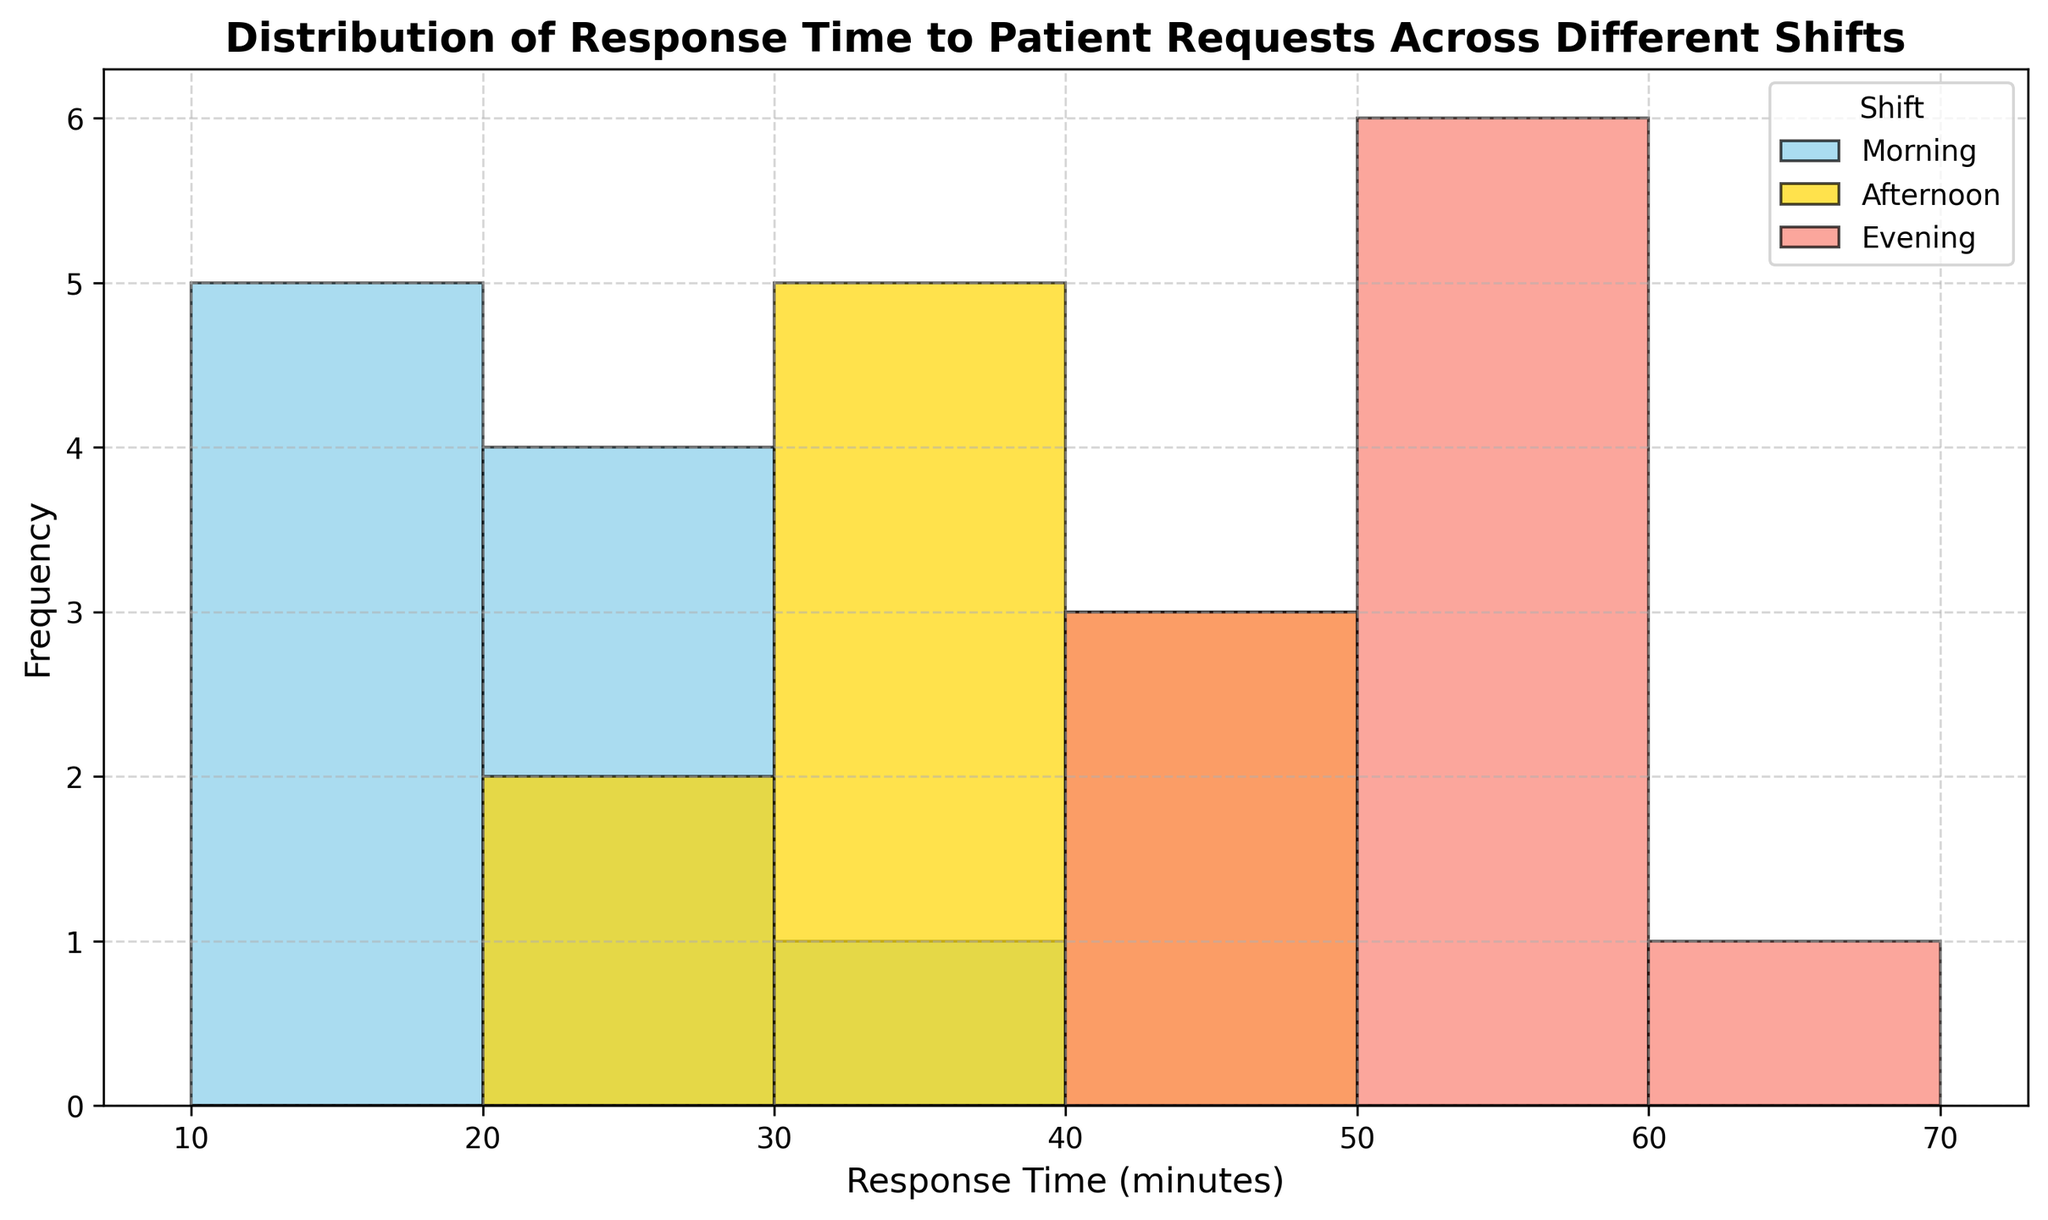What is the most frequent response time range for the Morning shift? To determine this, look at the histogram bars associated with the morning shift color (skyblue). The tallest bar within these is the most frequent range. The morning shift shows a tall bar in the 10-20 minute range.
Answer: 10-20 minutes Which shift has the highest range of response times? Observe the bins for each shift color to determine the range. The morning shift ranges from 10 to 30 minutes, the afternoon shift ranges from 25 to 45 minutes, and the evening shift ranges from 47 to 60 minutes. The evening shift has the broadest range, 13 minutes.
Answer: Evening What is the median response time for the Afternoon shift? To find the median, sort the afternoon shift response times and find the middle value. The response times are 25, 28, 30, 32, 33, 35, 38, 40, 42, and 45. The median value is the 5th and 6th values averaged, (33+35)/2 = 34.
Answer: 34 minutes Which shift has the largest spread in response times? The spread is determined by subtracting the minimum from the maximum response time within each shift. For the Morning shift: 30-10=20 minutes; for the Afternoon: 45-25=20 minutes; for the Evening: 60-47=13 minutes. The Morning and Afternoon shifts have the largest spreads at 20 minutes.
Answer: Morning and Afternoon Which shift has the lowest frequency of response times in the 30-40 minute range? Examine the height of the histogram bars in the 30-40 minute range for each color representing a shift. The morning shift has no bars in this range, indicating the lowest (zero) frequency.
Answer: Morning What fraction of response times in the Evening shift are greater than 50 minutes? Count the number of bins above the 50-minute mark and divide by the total number of evening responses. There are 4 bins (55, 60, 53, 58 minutes) above 50 minutes out of 10 total evening responses. Thus, the fraction is 4/10 or 0.4.
Answer: 0.4 Compare the frequency of response times between 10-20 minutes for Morning and Evening shifts. Which has more? For the Morning shift, count the height of the bars between 10-20 minutes. The Morning shift has 4 bars, while the Evening shift has zero bars in this range.
Answer: Morning shift What is the interquartile range (IQR) for the Morning shift? To calculate the IQR, first find the 1st quartile (Q1, 25th percentile) and 3rd quartile (Q3, 75th percentile) of the Morning shift data. The sorted data: 10, 12, 14, 15, 18, 20, 22, 25, 27, 30. Q1 is the 3rd value, 14, and Q3 is the 8th value, 25. IQR = Q3 - Q1 = 25 - 14 = 11 minutes.
Answer: 11 minutes 